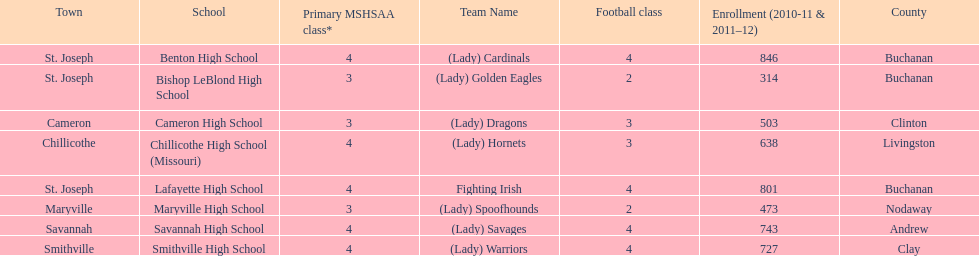Which schools are in the same town as bishop leblond? Benton High School, Lafayette High School. 